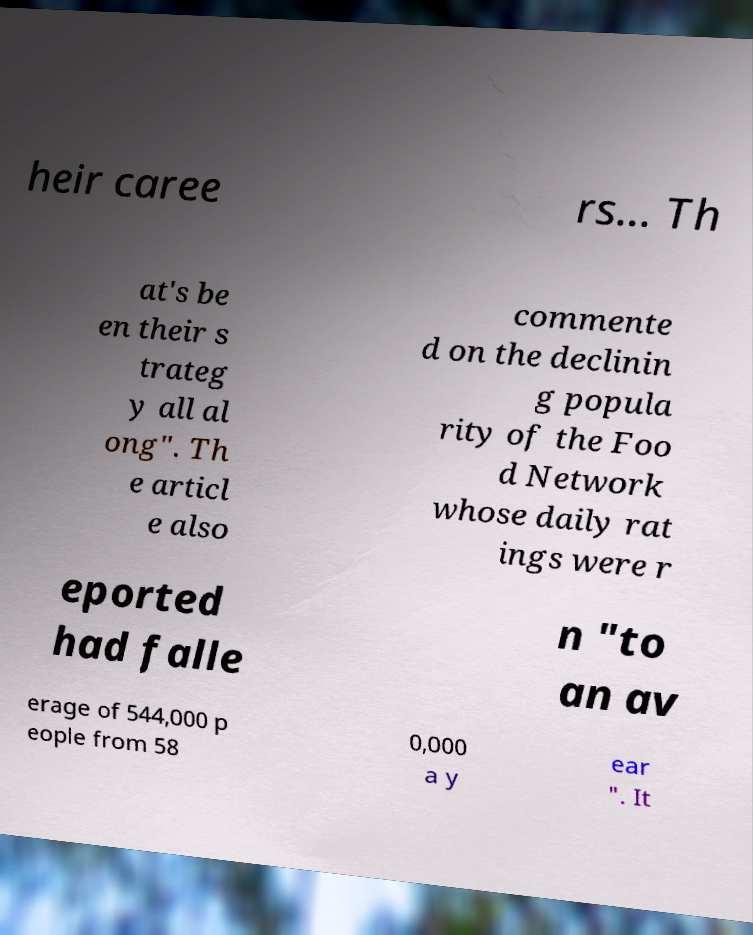For documentation purposes, I need the text within this image transcribed. Could you provide that? heir caree rs... Th at's be en their s trateg y all al ong". Th e articl e also commente d on the declinin g popula rity of the Foo d Network whose daily rat ings were r eported had falle n "to an av erage of 544,000 p eople from 58 0,000 a y ear ". It 